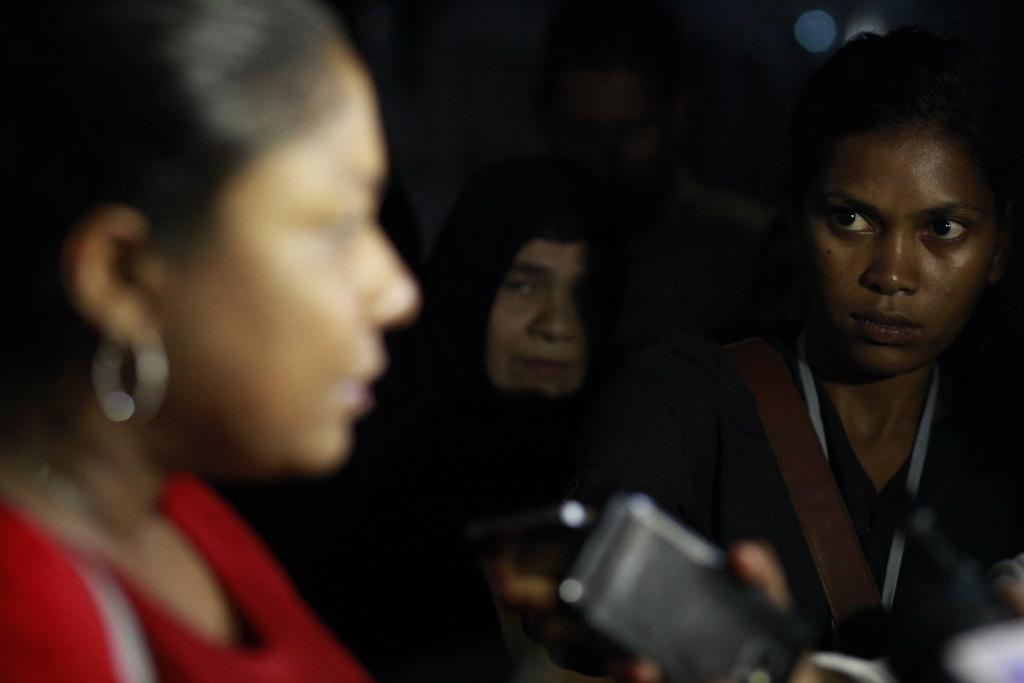Describe this image in one or two sentences. In this image there are people holding few objects in their hands, in the background it is blurred. 